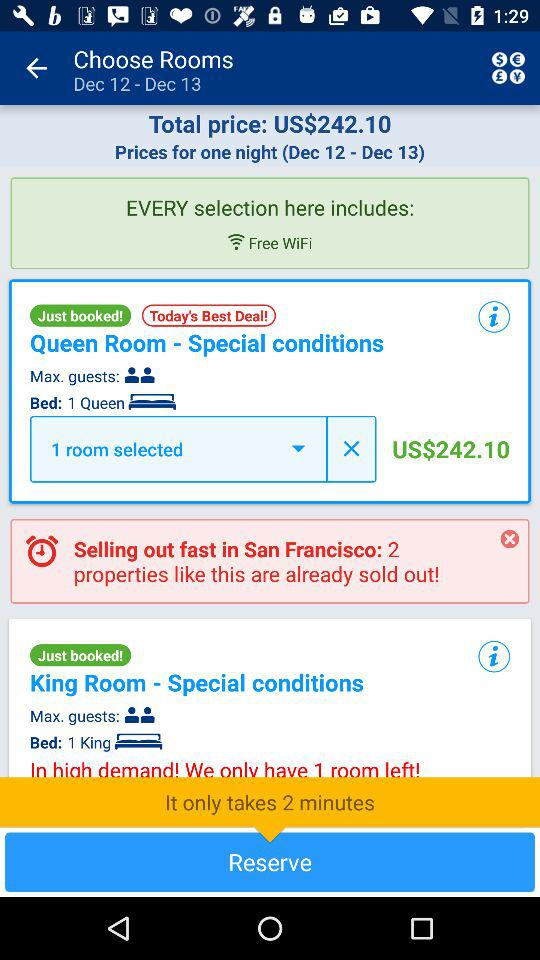What is the price for 1 night? The price for 1 night is US$242.10. 